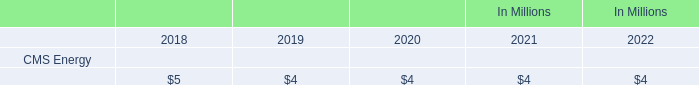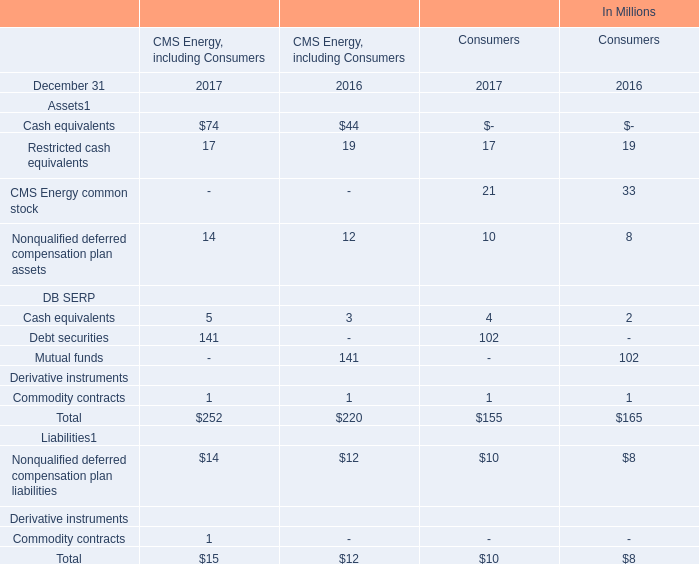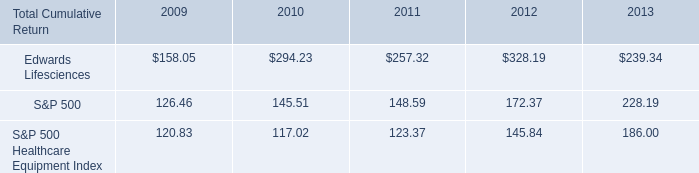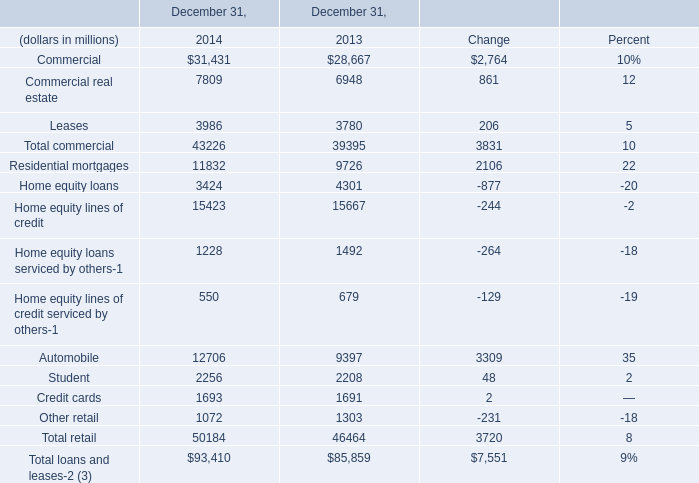In the year with the greatest proportion of Commercial?, what is the proportion of Commercial? to the tatal? 
Computations: (28667 / 39395)
Answer: 0.72768. 